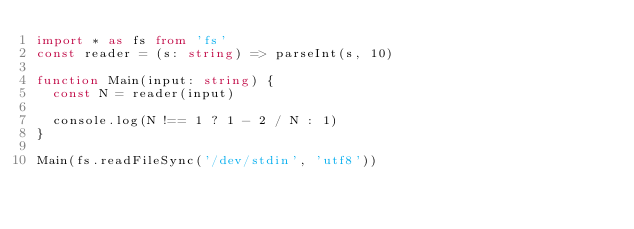Convert code to text. <code><loc_0><loc_0><loc_500><loc_500><_TypeScript_>import * as fs from 'fs'
const reader = (s: string) => parseInt(s, 10)

function Main(input: string) {
  const N = reader(input)

  console.log(N !== 1 ? 1 - 2 / N : 1)
}

Main(fs.readFileSync('/dev/stdin', 'utf8'))

</code> 